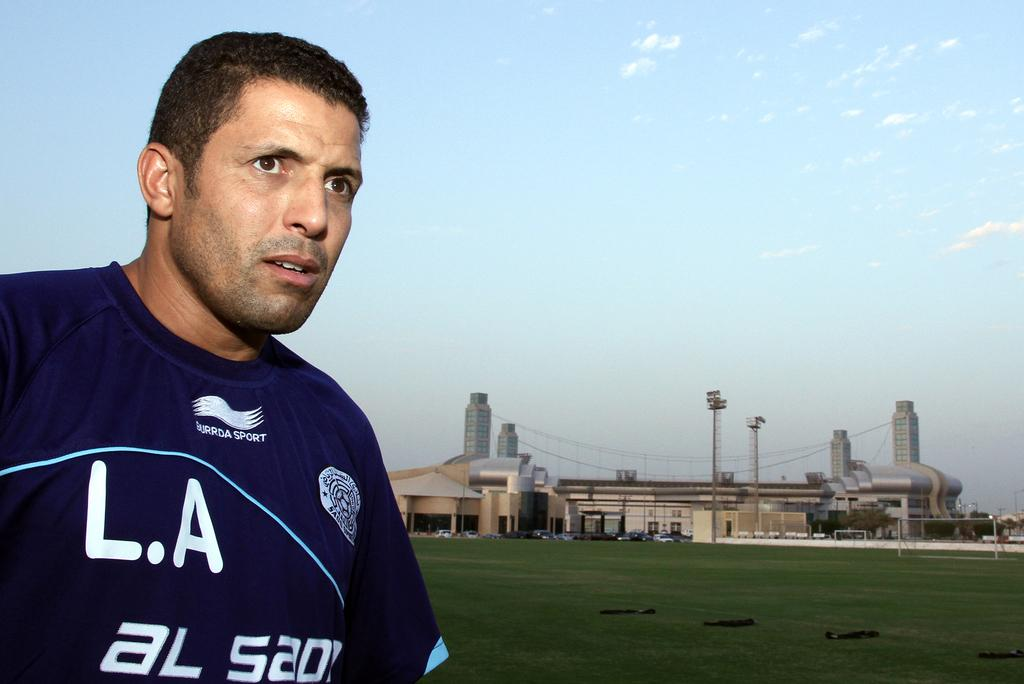<image>
Give a short and clear explanation of the subsequent image. A man is wearing a Burrda Sport brand jersey. 